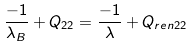Convert formula to latex. <formula><loc_0><loc_0><loc_500><loc_500>\frac { - 1 } { \lambda _ { B } } + Q _ { 2 2 } = \frac { - 1 } { \lambda } + Q _ { r e n 2 2 }</formula> 